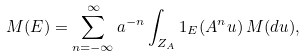<formula> <loc_0><loc_0><loc_500><loc_500>M ( E ) = \sum _ { n = - \infty } ^ { \infty } a ^ { - n } \int _ { Z _ { A } } 1 _ { E } ( A ^ { n } u ) \, M ( d u ) ,</formula> 